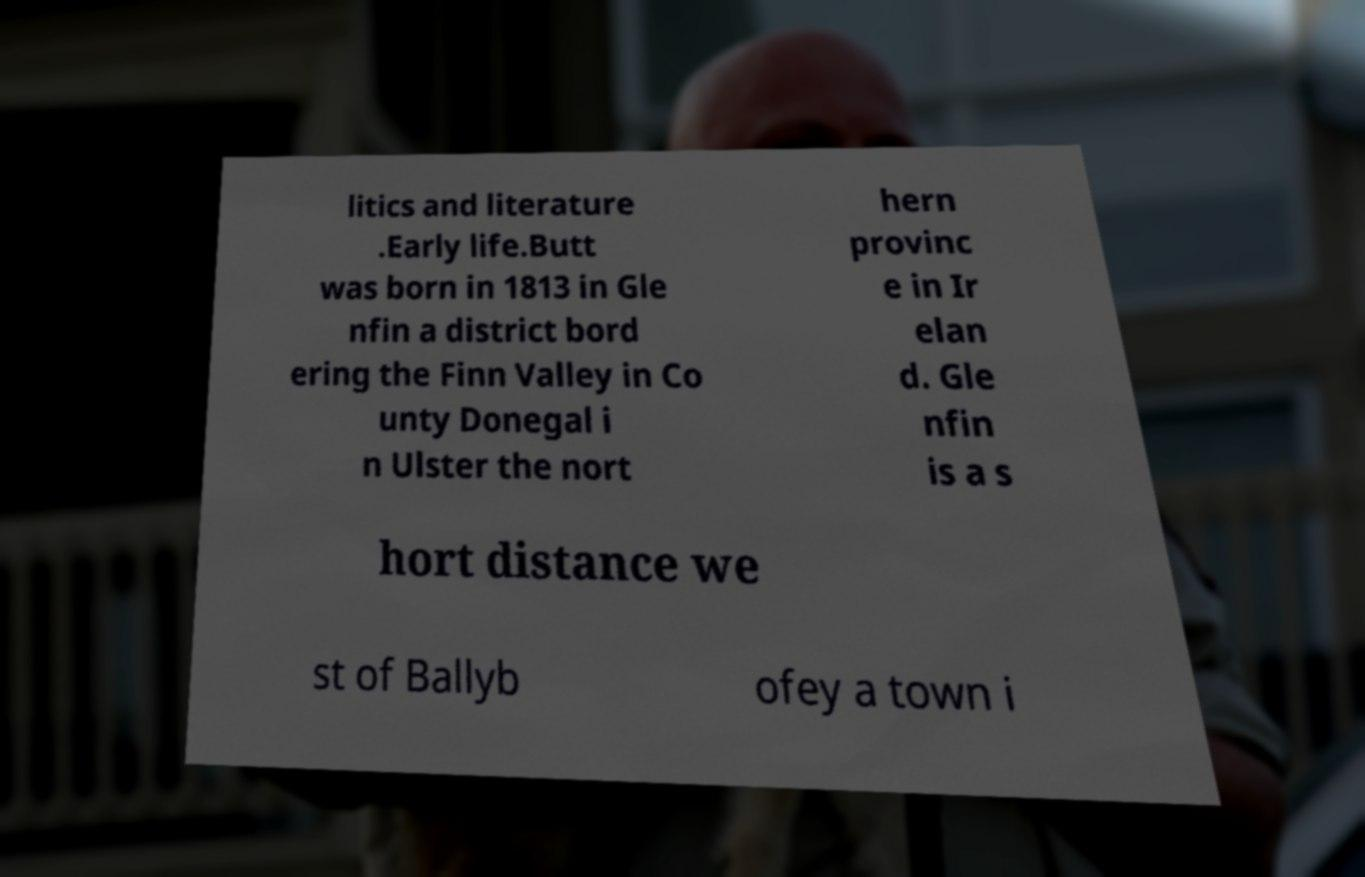Please read and relay the text visible in this image. What does it say? litics and literature .Early life.Butt was born in 1813 in Gle nfin a district bord ering the Finn Valley in Co unty Donegal i n Ulster the nort hern provinc e in Ir elan d. Gle nfin is a s hort distance we st of Ballyb ofey a town i 